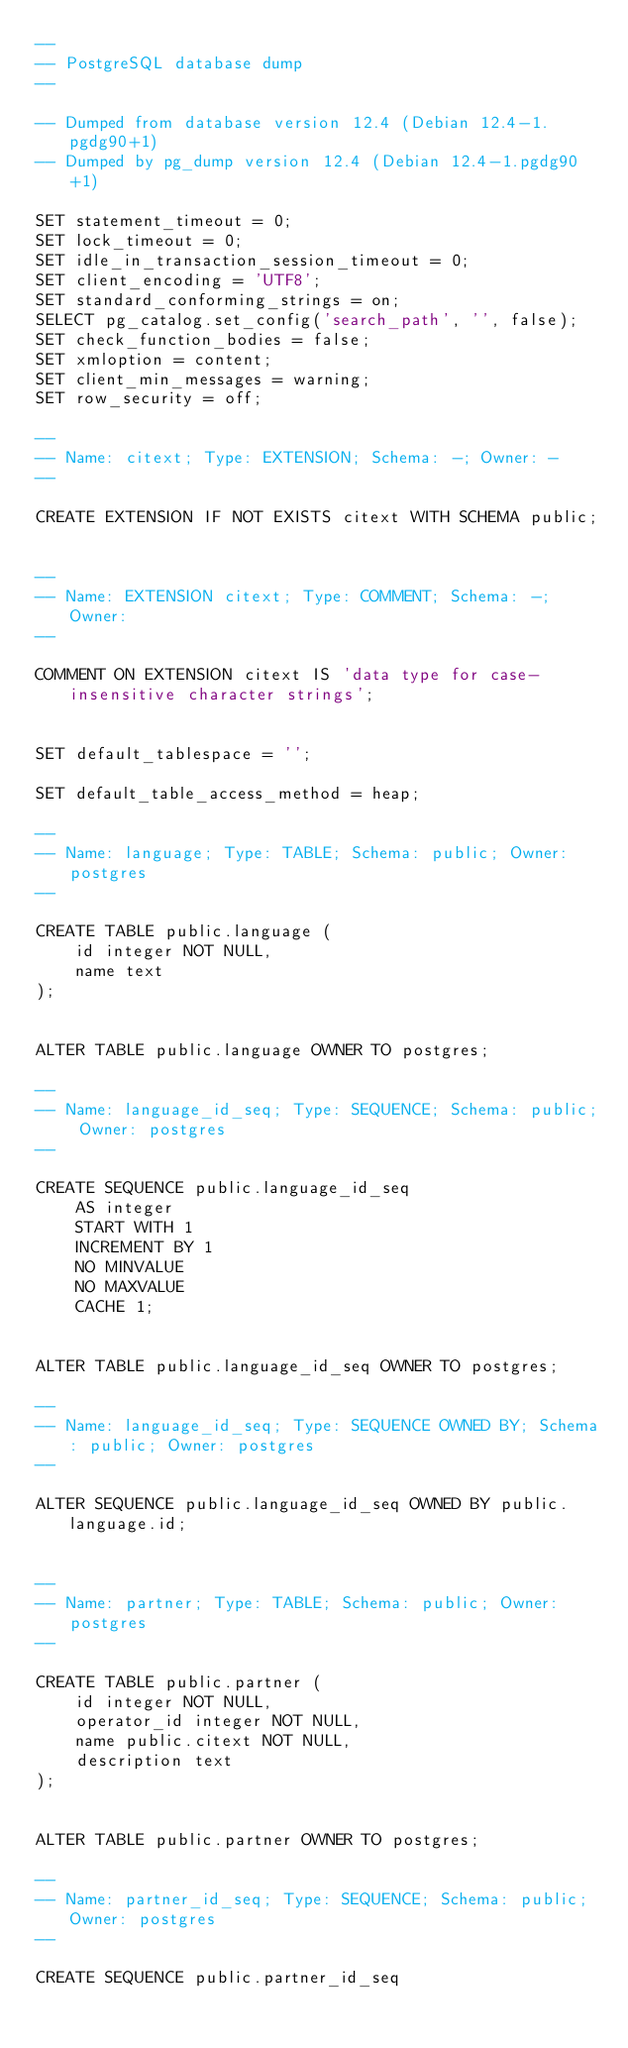<code> <loc_0><loc_0><loc_500><loc_500><_SQL_>--
-- PostgreSQL database dump
--

-- Dumped from database version 12.4 (Debian 12.4-1.pgdg90+1)
-- Dumped by pg_dump version 12.4 (Debian 12.4-1.pgdg90+1)

SET statement_timeout = 0;
SET lock_timeout = 0;
SET idle_in_transaction_session_timeout = 0;
SET client_encoding = 'UTF8';
SET standard_conforming_strings = on;
SELECT pg_catalog.set_config('search_path', '', false);
SET check_function_bodies = false;
SET xmloption = content;
SET client_min_messages = warning;
SET row_security = off;

--
-- Name: citext; Type: EXTENSION; Schema: -; Owner: -
--

CREATE EXTENSION IF NOT EXISTS citext WITH SCHEMA public;


--
-- Name: EXTENSION citext; Type: COMMENT; Schema: -; Owner: 
--

COMMENT ON EXTENSION citext IS 'data type for case-insensitive character strings';


SET default_tablespace = '';

SET default_table_access_method = heap;

--
-- Name: language; Type: TABLE; Schema: public; Owner: postgres
--

CREATE TABLE public.language (
    id integer NOT NULL,
    name text
);


ALTER TABLE public.language OWNER TO postgres;

--
-- Name: language_id_seq; Type: SEQUENCE; Schema: public; Owner: postgres
--

CREATE SEQUENCE public.language_id_seq
    AS integer
    START WITH 1
    INCREMENT BY 1
    NO MINVALUE
    NO MAXVALUE
    CACHE 1;


ALTER TABLE public.language_id_seq OWNER TO postgres;

--
-- Name: language_id_seq; Type: SEQUENCE OWNED BY; Schema: public; Owner: postgres
--

ALTER SEQUENCE public.language_id_seq OWNED BY public.language.id;


--
-- Name: partner; Type: TABLE; Schema: public; Owner: postgres
--

CREATE TABLE public.partner (
    id integer NOT NULL,
    operator_id integer NOT NULL,
    name public.citext NOT NULL,
    description text
);


ALTER TABLE public.partner OWNER TO postgres;

--
-- Name: partner_id_seq; Type: SEQUENCE; Schema: public; Owner: postgres
--

CREATE SEQUENCE public.partner_id_seq</code> 